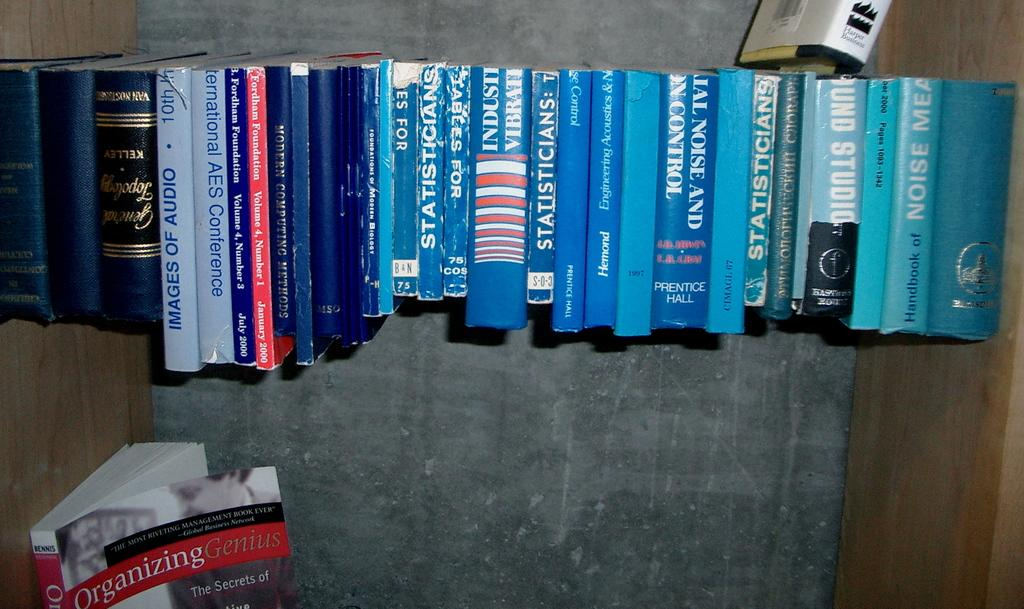<image>
Summarize the visual content of the image. a book about statisticians next to other books 